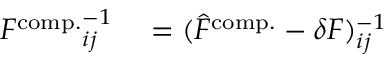Convert formula to latex. <formula><loc_0><loc_0><loc_500><loc_500>\begin{array} { r l } { { F ^ { c o m p . } } _ { i j } ^ { - 1 } } & = ( \hat { F } ^ { c o m p . } - \delta F ) _ { i j } ^ { - 1 } } \end{array}</formula> 